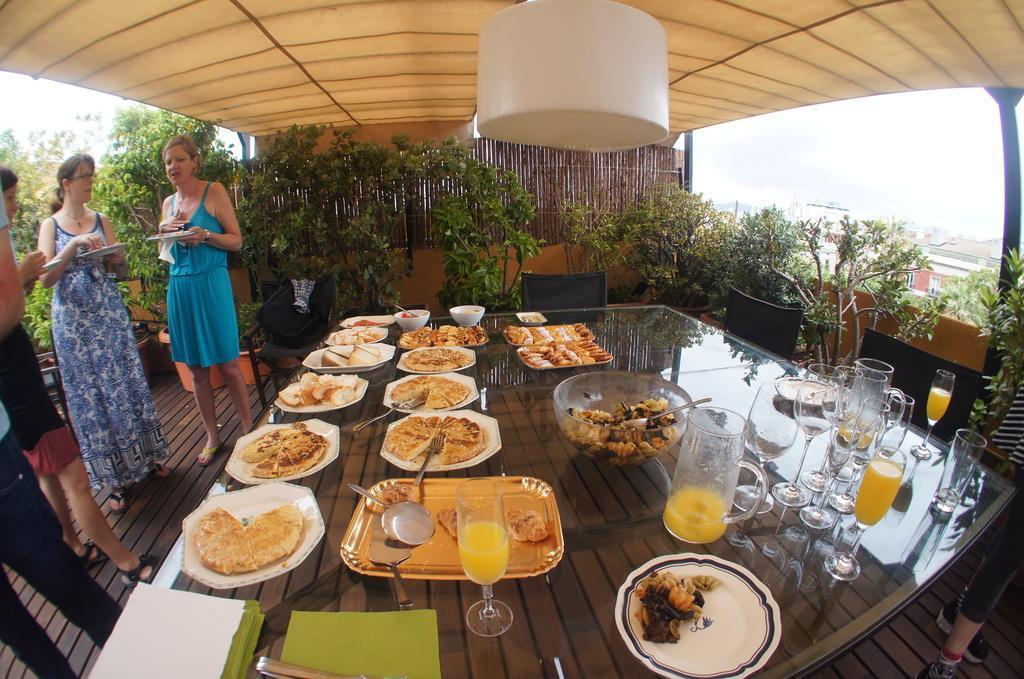Describe this image in one or two sentences. This image consists of a dining table, chairs and three people on the left side ,there are so many shrubs in this image, there is light on the top, this dining table consists of plates, glasses, spoons, tissues and there are so many edibles on dining table. There is a jar too. 